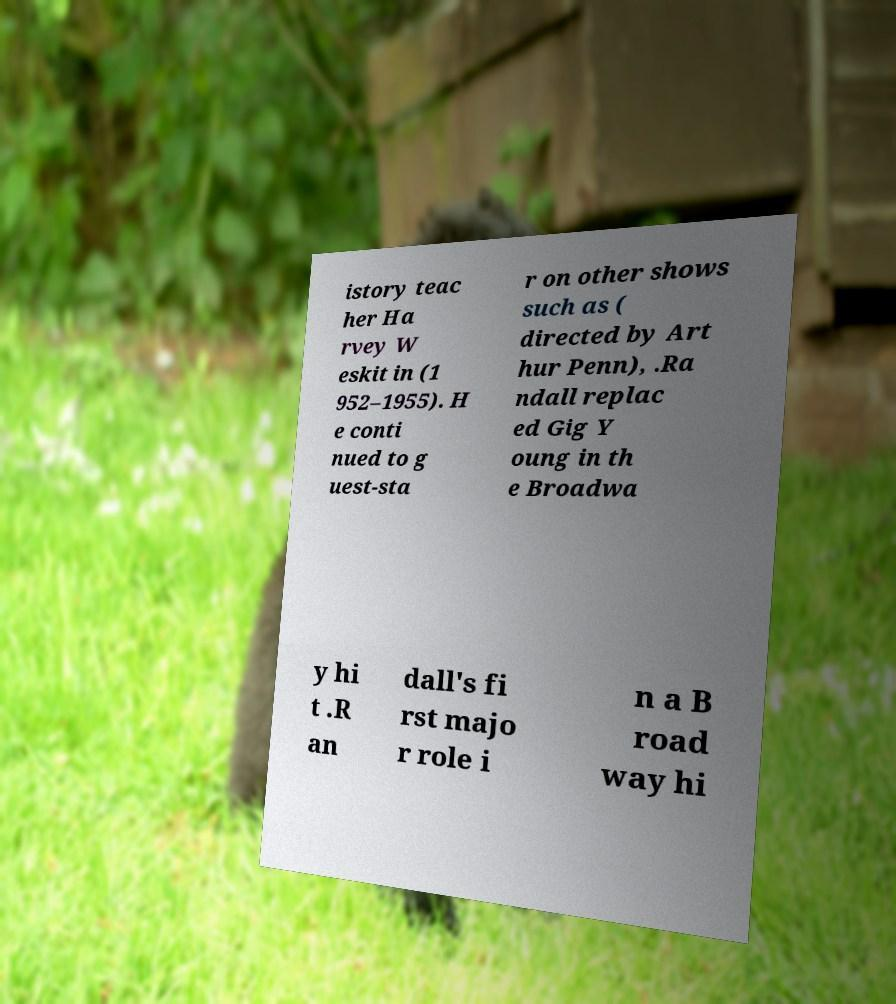I need the written content from this picture converted into text. Can you do that? istory teac her Ha rvey W eskit in (1 952–1955). H e conti nued to g uest-sta r on other shows such as ( directed by Art hur Penn), .Ra ndall replac ed Gig Y oung in th e Broadwa y hi t .R an dall's fi rst majo r role i n a B road way hi 